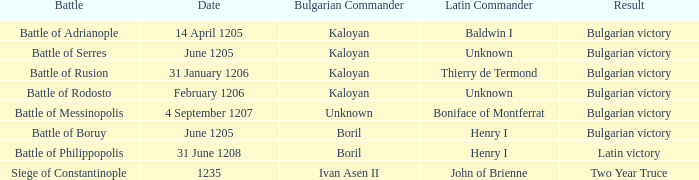What is the bulgarian chief of the battle of rusion? Kaloyan. 